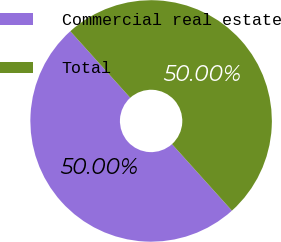<chart> <loc_0><loc_0><loc_500><loc_500><pie_chart><fcel>Commercial real estate<fcel>Total<nl><fcel>50.0%<fcel>50.0%<nl></chart> 